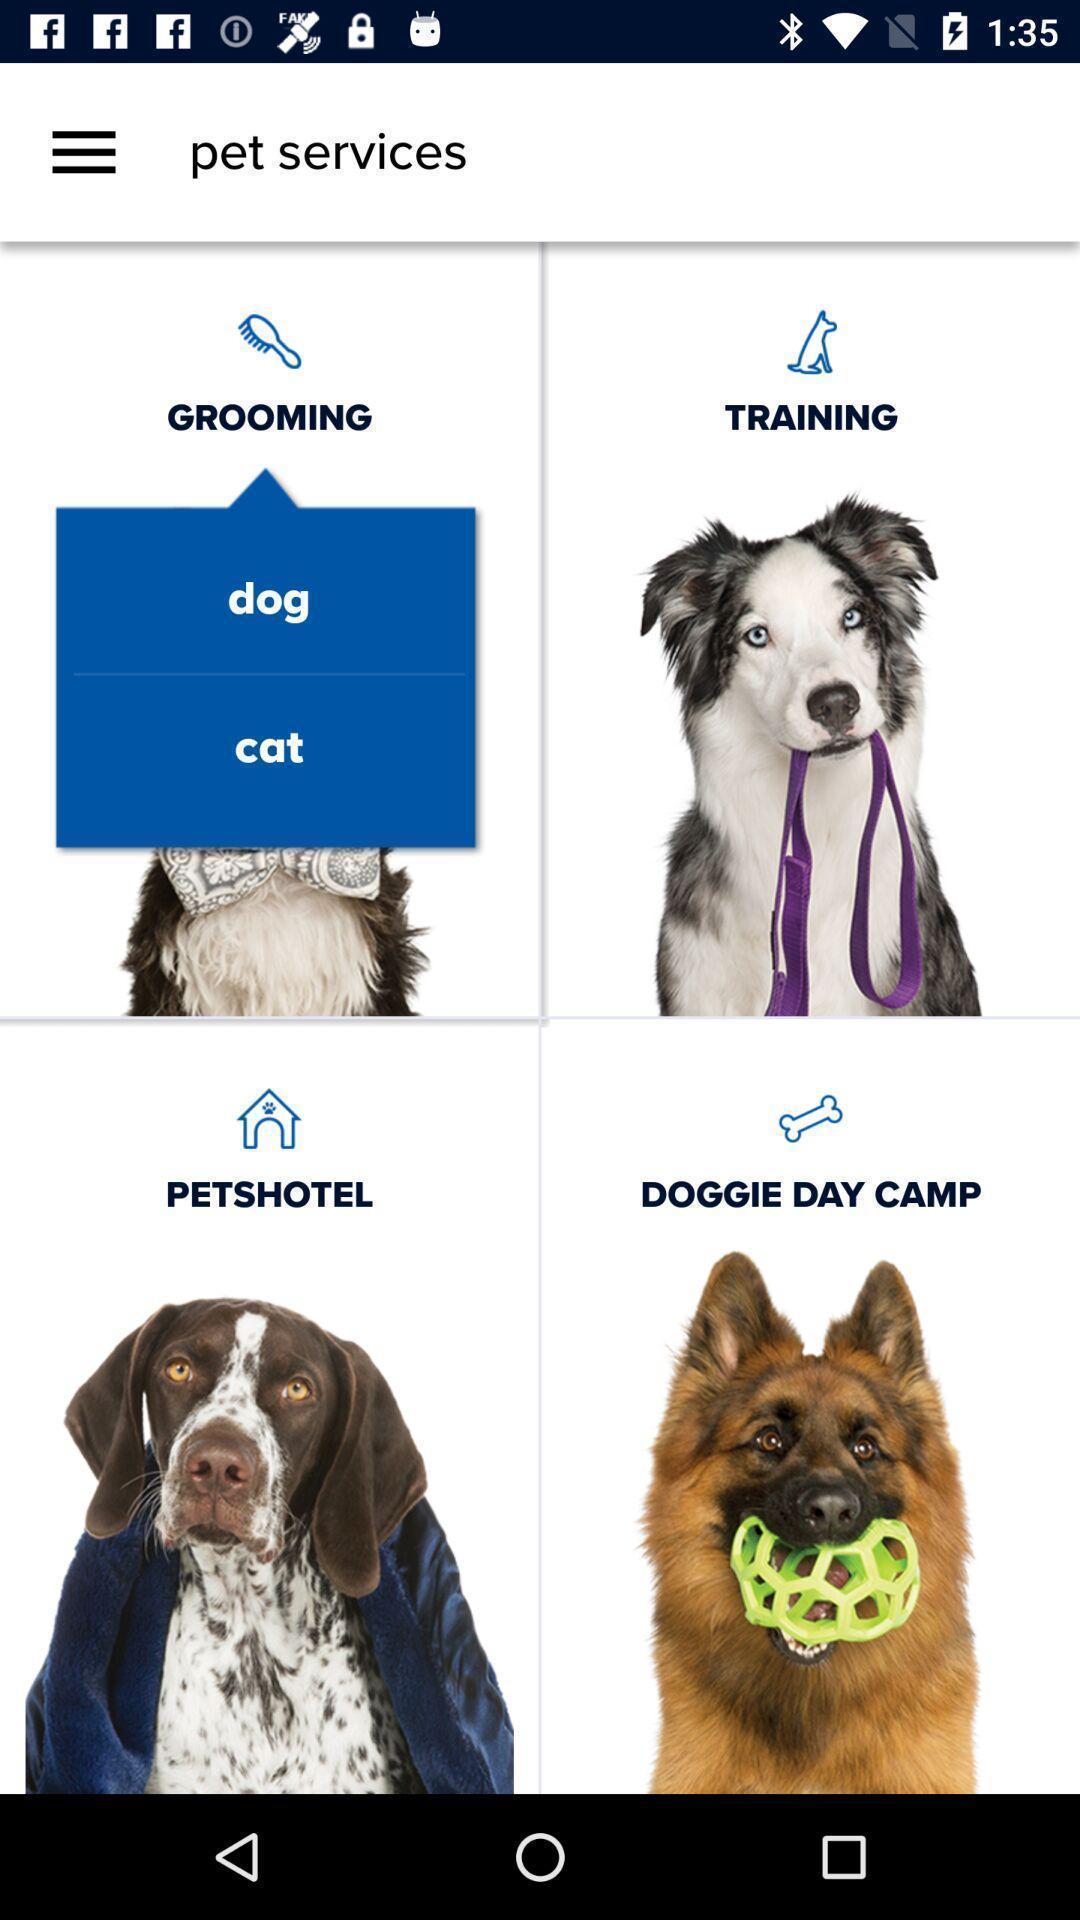Explain what's happening in this screen capture. Screen displaying various dog images. 